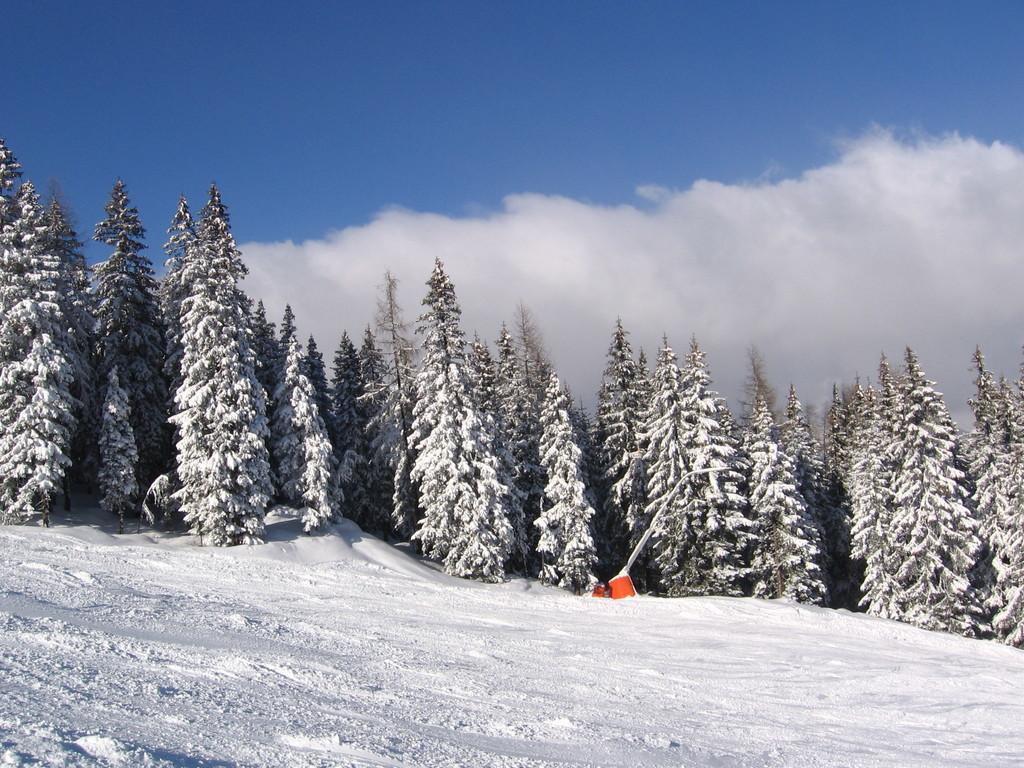How would you summarize this image in a sentence or two? In this picture I can see snow. I can see trees in the background. I can see clouds in the sky. 